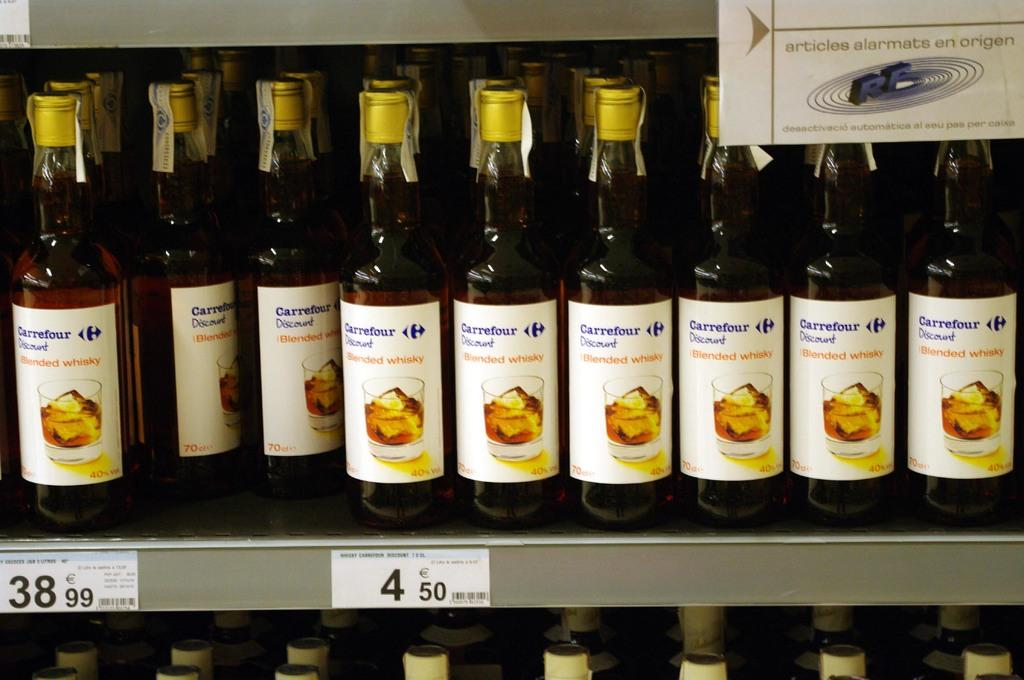<image>
Share a concise interpretation of the image provided. Shelf of bottles that are labeled with Carrefour discount 